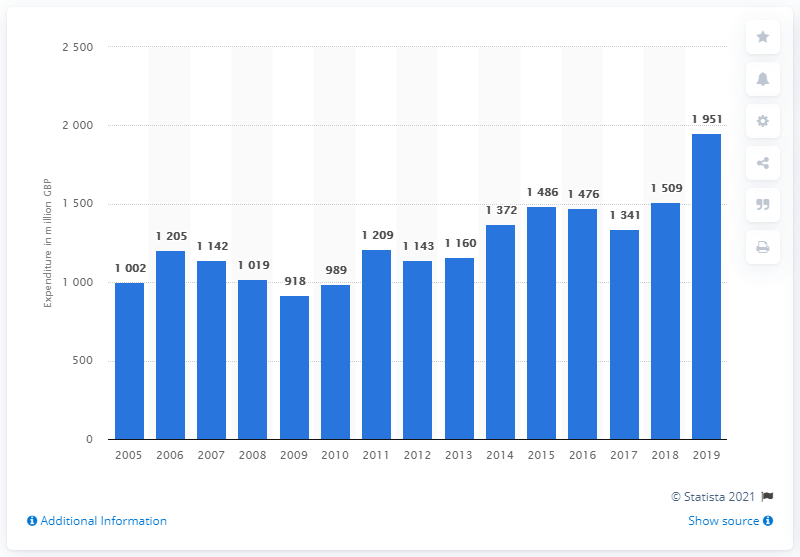Point out several critical features in this image. In 2019, households in the UK purchased a significant quantity of small electric household appliances, with a total value of 1951 pounds. 